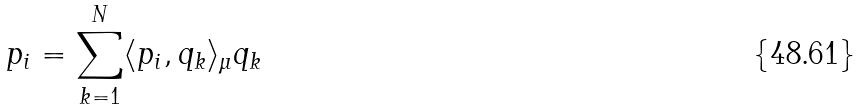Convert formula to latex. <formula><loc_0><loc_0><loc_500><loc_500>p _ { i } = \sum _ { k = 1 } ^ { N } \langle p _ { i } , q _ { k } \rangle _ { \mu } q _ { k }</formula> 